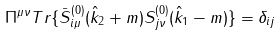<formula> <loc_0><loc_0><loc_500><loc_500>\Pi ^ { \mu \nu } T r \{ \bar { S } ^ { ( 0 ) } _ { i \mu } ( \hat { k } _ { 2 } + m ) S ^ { ( 0 ) } _ { j \nu } ( \hat { k } _ { 1 } - m ) \} = \delta _ { i j }</formula> 